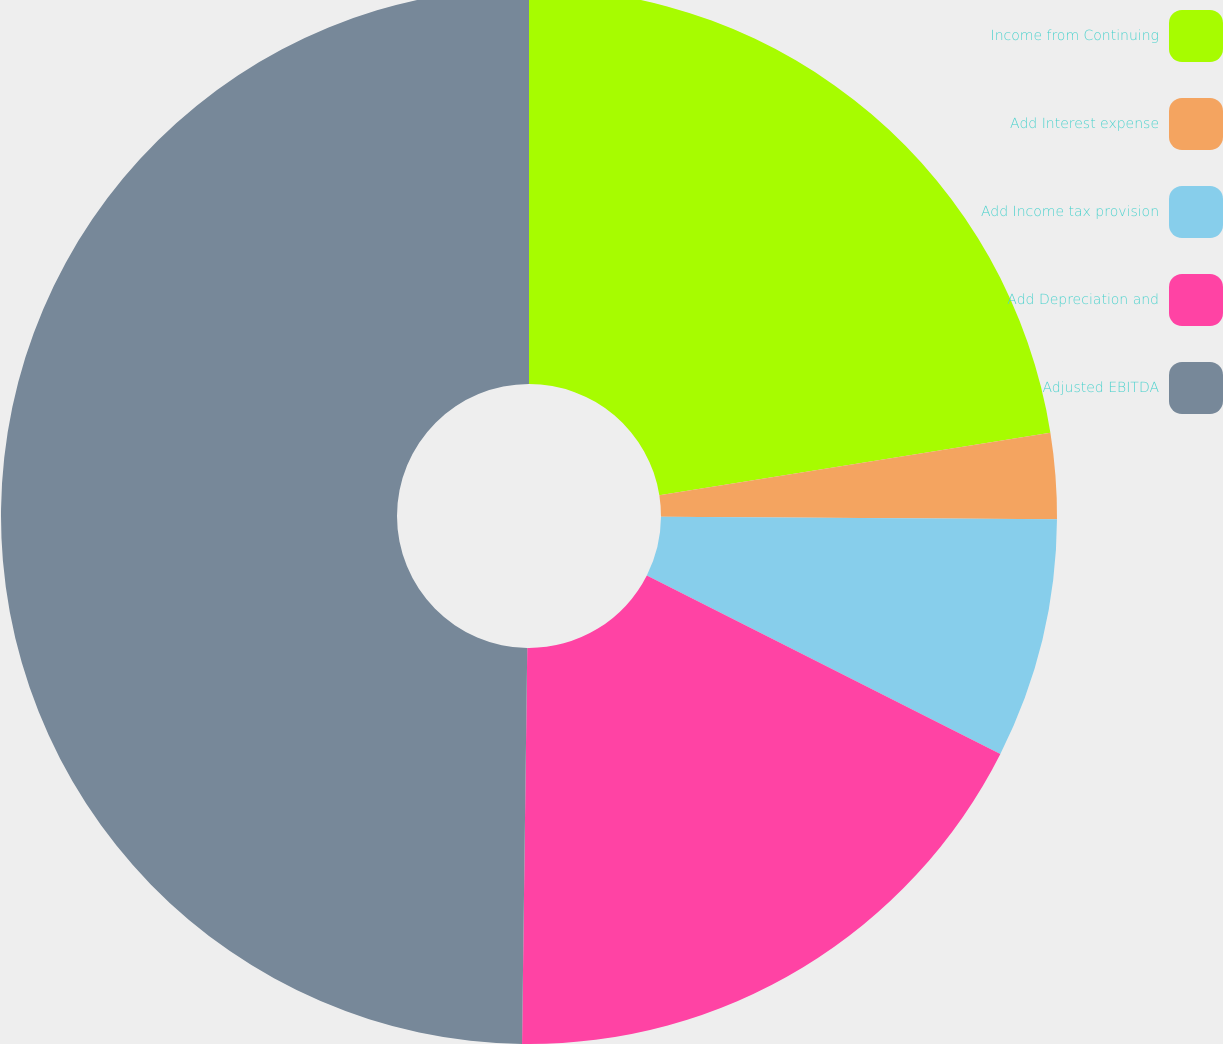Convert chart. <chart><loc_0><loc_0><loc_500><loc_500><pie_chart><fcel>Income from Continuing<fcel>Add Interest expense<fcel>Add Income tax provision<fcel>Add Depreciation and<fcel>Adjusted EBITDA<nl><fcel>22.48%<fcel>2.62%<fcel>7.34%<fcel>17.77%<fcel>49.79%<nl></chart> 